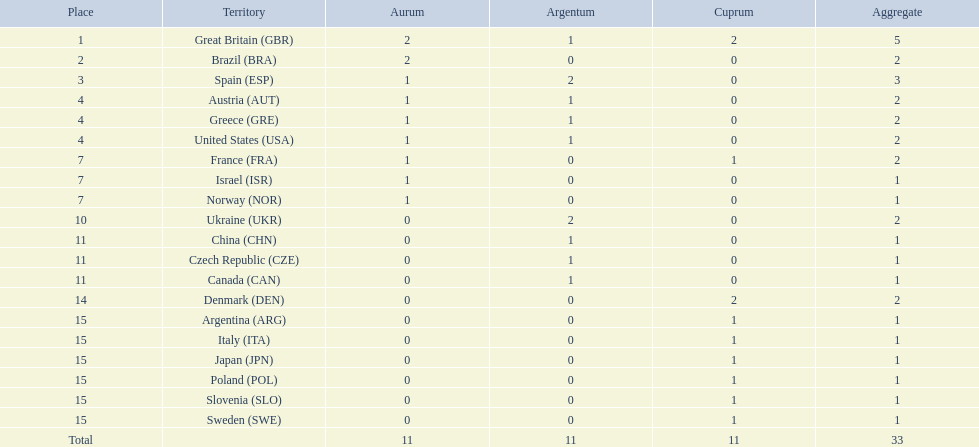How many medals did each country receive? 5, 2, 3, 2, 2, 2, 2, 1, 1, 2, 1, 1, 1, 2, 1, 1, 1, 1, 1, 1. Which country received 3 medals? Spain (ESP). 